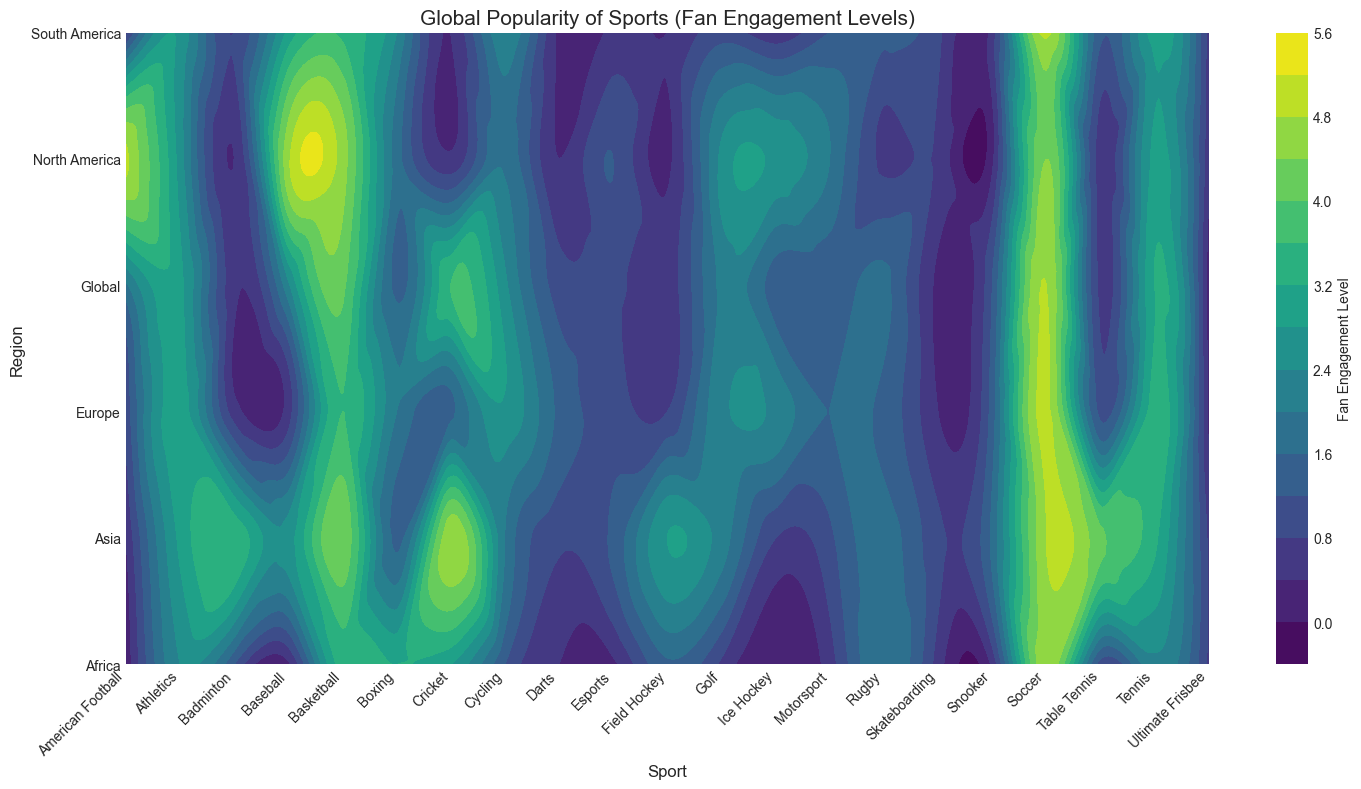Which region has the highest fan engagement for Soccer? The contour plot allows us to observe that the highest concentration of engagement for Soccer lies in both Europe and South America, where fan engagement reaches nearly 4.9.
Answer: Europe and South America Which sport has the lowest fan engagement in North America? By examining the contour plot, the lowest engagement level in North America appears in Cricket, Rugby, Field Hockey, and Snooker, all of which have engagement levels below or equal to 0.5.
Answer: Cricket, Rugby, Field Hockey, Snooker Compare the fan engagement levels for Baseball in North America and Europe. Which region shows greater engagement? The contour plot shows Baseball in North America has a significantly higher engagement level of 4.7 compared to Europe, which is at 0.6.
Answer: North America What is the average fan engagement level for Cycling across all six regions? To find the average fan engagement for Cycling, we sum the engagement levels across Global (2.5), Europe (2.7), North America (1.9), South America (2.3), Africa (1.2), and Asia (2.0) and divide by 6. (2.5 + 2.7 + 1.9 + 2.3 + 1.2 + 2.0)/6 = 2.1
Answer: 2.1 In which region does Basketball have higher fan engagement compared to Cycling? From the contour plot, Basketball has higher engagement than Cycling in all regions except Africa, Europe, and South America, where both have engagement levels lower than their counterparts.
Answer: Global, North America, Asia What sports are more popular than Cycling in Asia in terms of fan engagement? Looking at the contour plot for Asia, Soccer, Cricket, Basketball, Tennis, and Table Tennis have notably higher fan engagement levels than Cycling.
Answer: Soccer, Cricket, Basketball, Tennis, Table Tennis Compare the fan engagement in Tennis between Europe and Asia. The contour plot shows Tennis engagement in Europe is approximately 3.4, slightly higher than in Asia where it is around 3.3.
Answer: Europe Find the difference in fan engagement for Athletics between Africa and North America. From the contour plot, Athletics in Africa shows an engagement level of around 2.4, while North America has approximately 2.6, resulting in a difference of 2.6 - 2.4 = 0.2.
Answer: 0.2 What is the fan engagement level for Esports globally versus in Asia? In the contour plot, Esports globally has an engagement level of 0.9, whereas in Asia it is marked at 1.3.
Answer: 0.9 (Global) and 1.3 (Asia) 